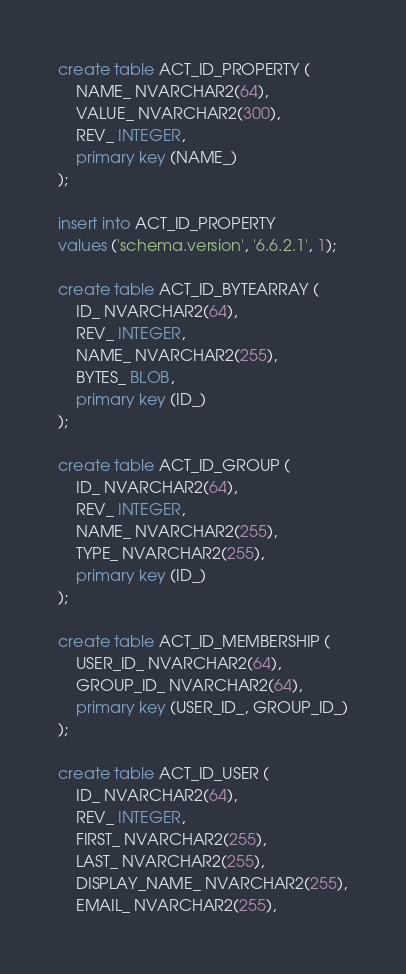Convert code to text. <code><loc_0><loc_0><loc_500><loc_500><_SQL_>create table ACT_ID_PROPERTY (
    NAME_ NVARCHAR2(64),
    VALUE_ NVARCHAR2(300),
    REV_ INTEGER,
    primary key (NAME_)
);

insert into ACT_ID_PROPERTY
values ('schema.version', '6.6.2.1', 1);

create table ACT_ID_BYTEARRAY (
    ID_ NVARCHAR2(64),
    REV_ INTEGER,
    NAME_ NVARCHAR2(255),
    BYTES_ BLOB,
    primary key (ID_)
);

create table ACT_ID_GROUP (
    ID_ NVARCHAR2(64),
    REV_ INTEGER,
    NAME_ NVARCHAR2(255),
    TYPE_ NVARCHAR2(255),
    primary key (ID_)
);

create table ACT_ID_MEMBERSHIP (
    USER_ID_ NVARCHAR2(64),
    GROUP_ID_ NVARCHAR2(64),
    primary key (USER_ID_, GROUP_ID_)
);

create table ACT_ID_USER (
    ID_ NVARCHAR2(64),
    REV_ INTEGER,
    FIRST_ NVARCHAR2(255),
    LAST_ NVARCHAR2(255),
    DISPLAY_NAME_ NVARCHAR2(255),
    EMAIL_ NVARCHAR2(255),</code> 